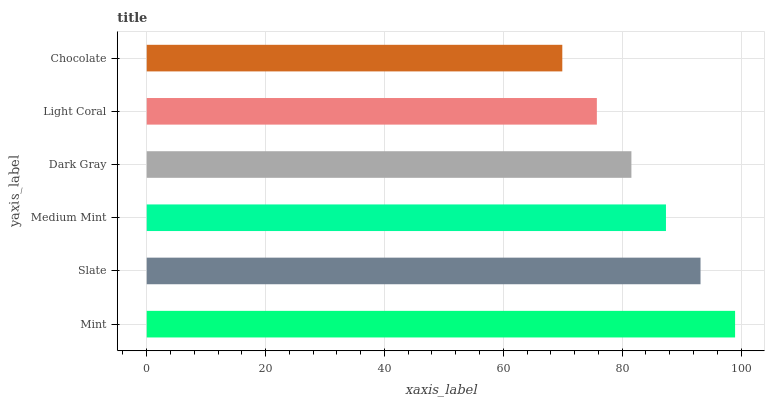Is Chocolate the minimum?
Answer yes or no. Yes. Is Mint the maximum?
Answer yes or no. Yes. Is Slate the minimum?
Answer yes or no. No. Is Slate the maximum?
Answer yes or no. No. Is Mint greater than Slate?
Answer yes or no. Yes. Is Slate less than Mint?
Answer yes or no. Yes. Is Slate greater than Mint?
Answer yes or no. No. Is Mint less than Slate?
Answer yes or no. No. Is Medium Mint the high median?
Answer yes or no. Yes. Is Dark Gray the low median?
Answer yes or no. Yes. Is Mint the high median?
Answer yes or no. No. Is Light Coral the low median?
Answer yes or no. No. 